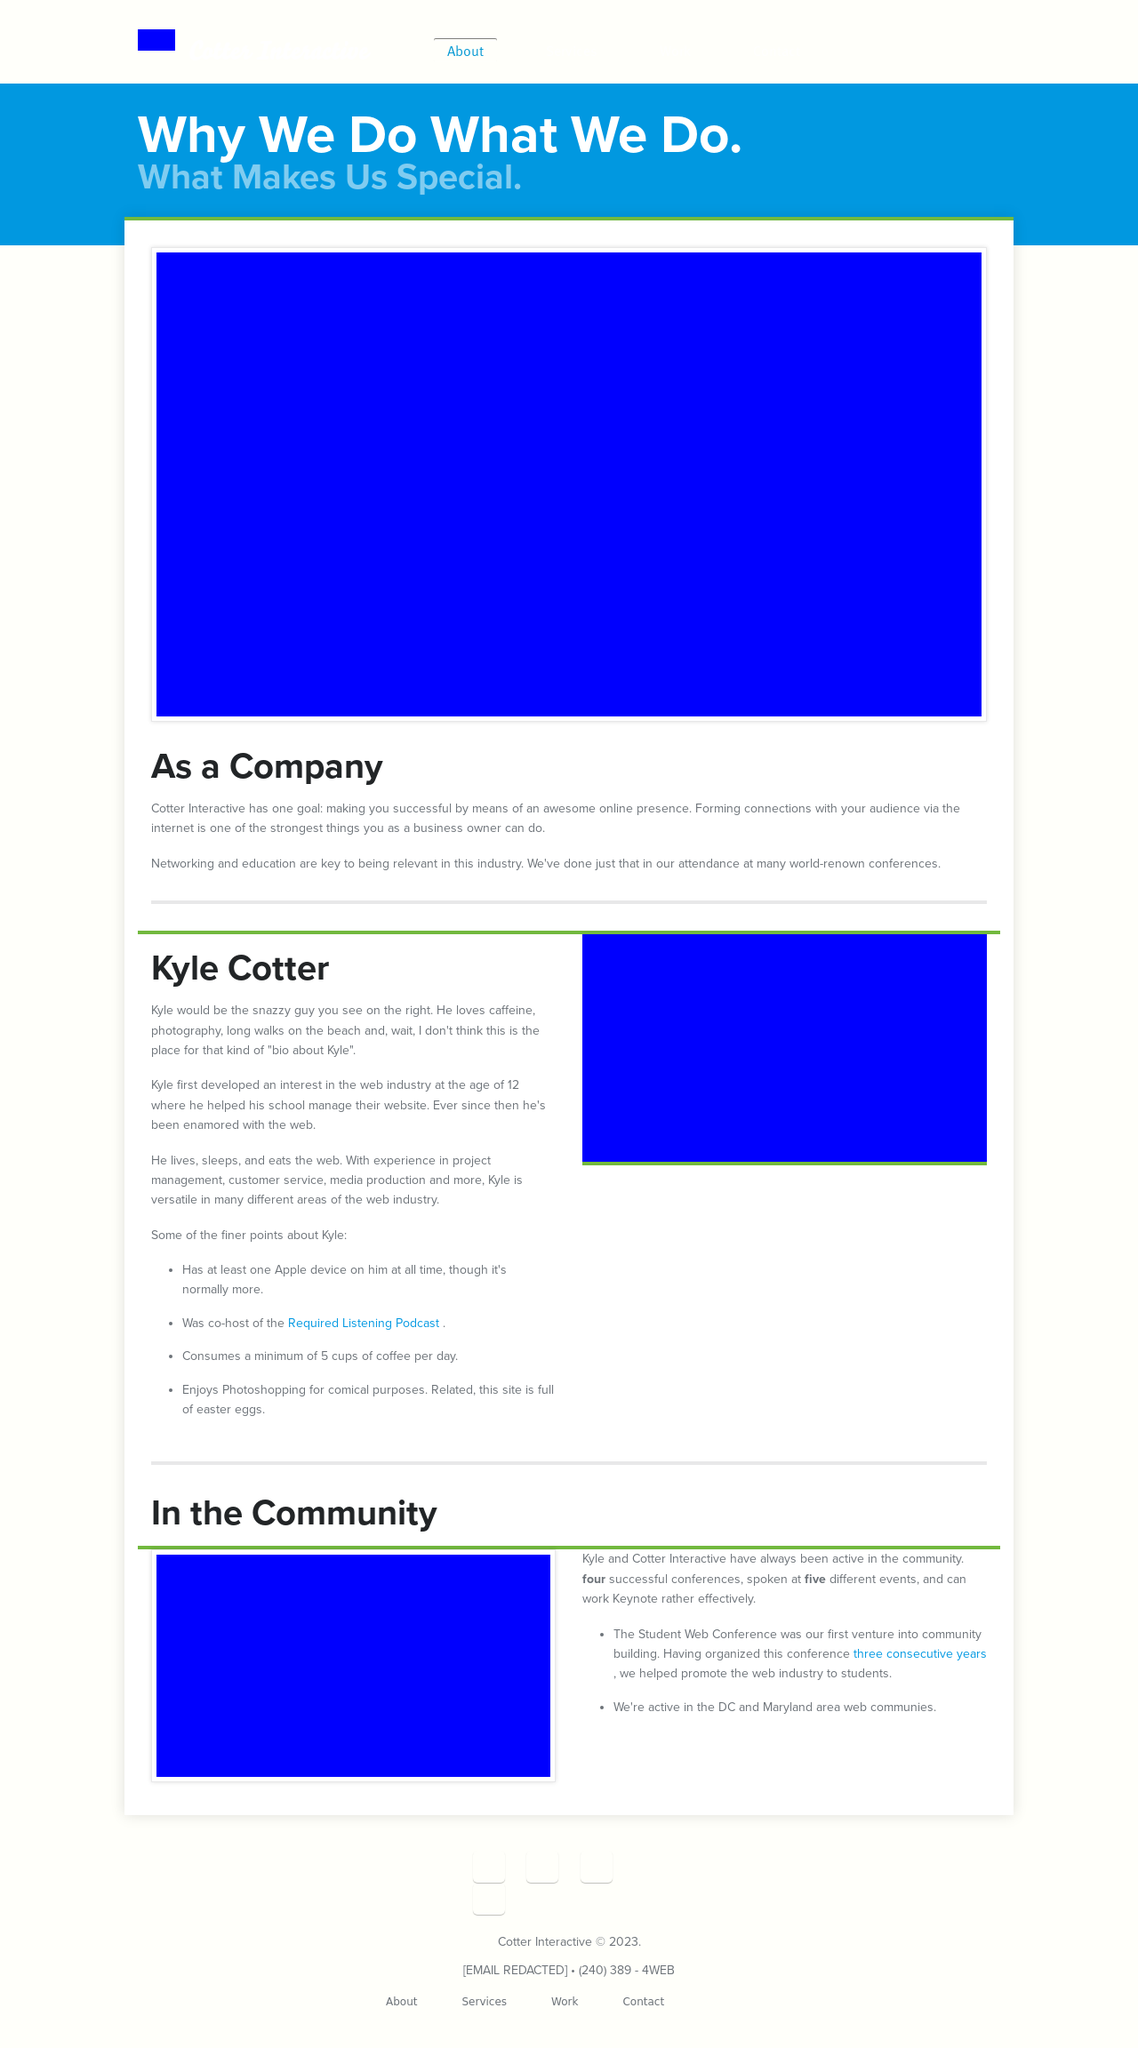What's the procedure for constructing this website from scratch with HTML? To build the website shown from scratch using HTML, start with a basic HTML5 template. Include doctype declaration and meta tags to ensure compatibility and responsiveness. The structure will benefit from semantic HTML5 elements such as <header>, <nav>, <section>, and <footer> to organize content meaningfully. Ensure to include external CSS for styling and JavaScript files for functionality. The example provided is a well-structured foundation with specific classes assigned for easy styling and efficient layout management. 